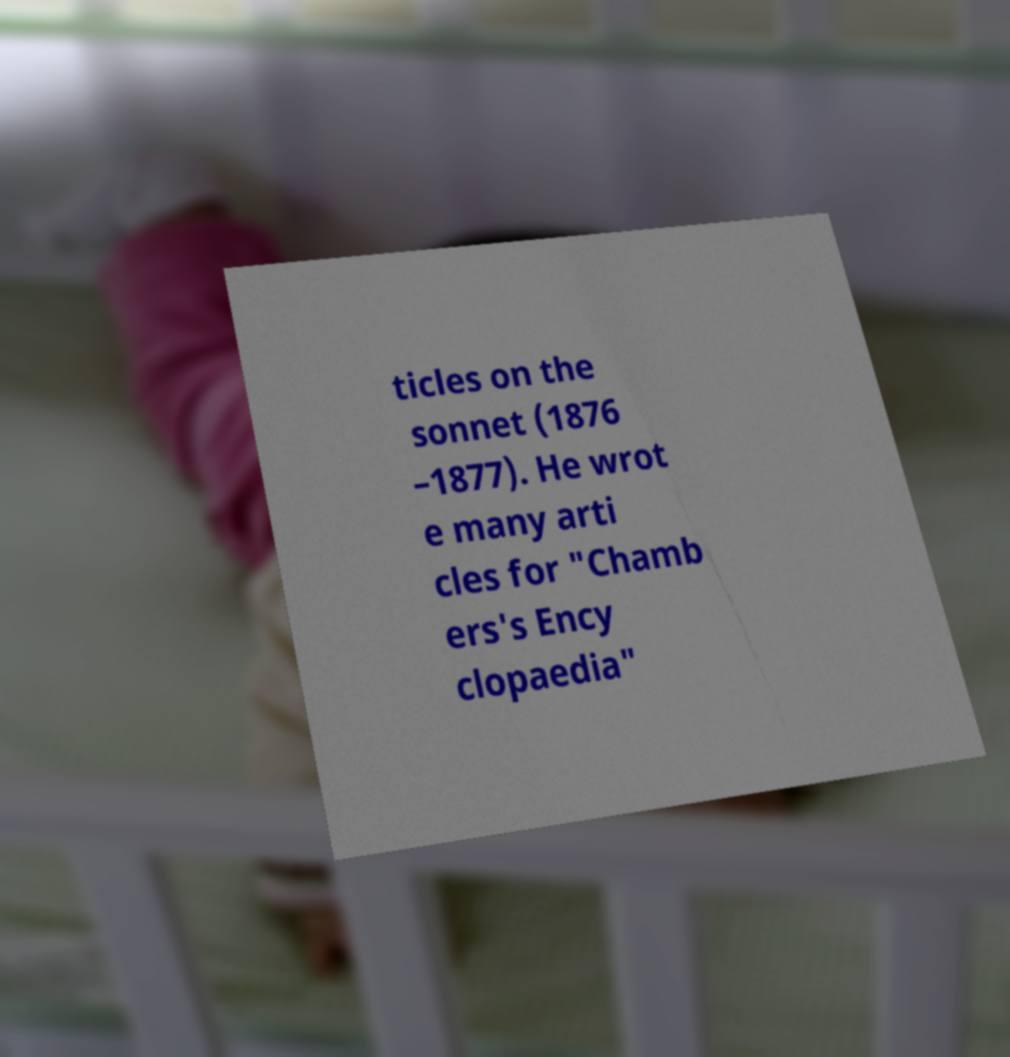What messages or text are displayed in this image? I need them in a readable, typed format. ticles on the sonnet (1876 –1877). He wrot e many arti cles for "Chamb ers's Ency clopaedia" 